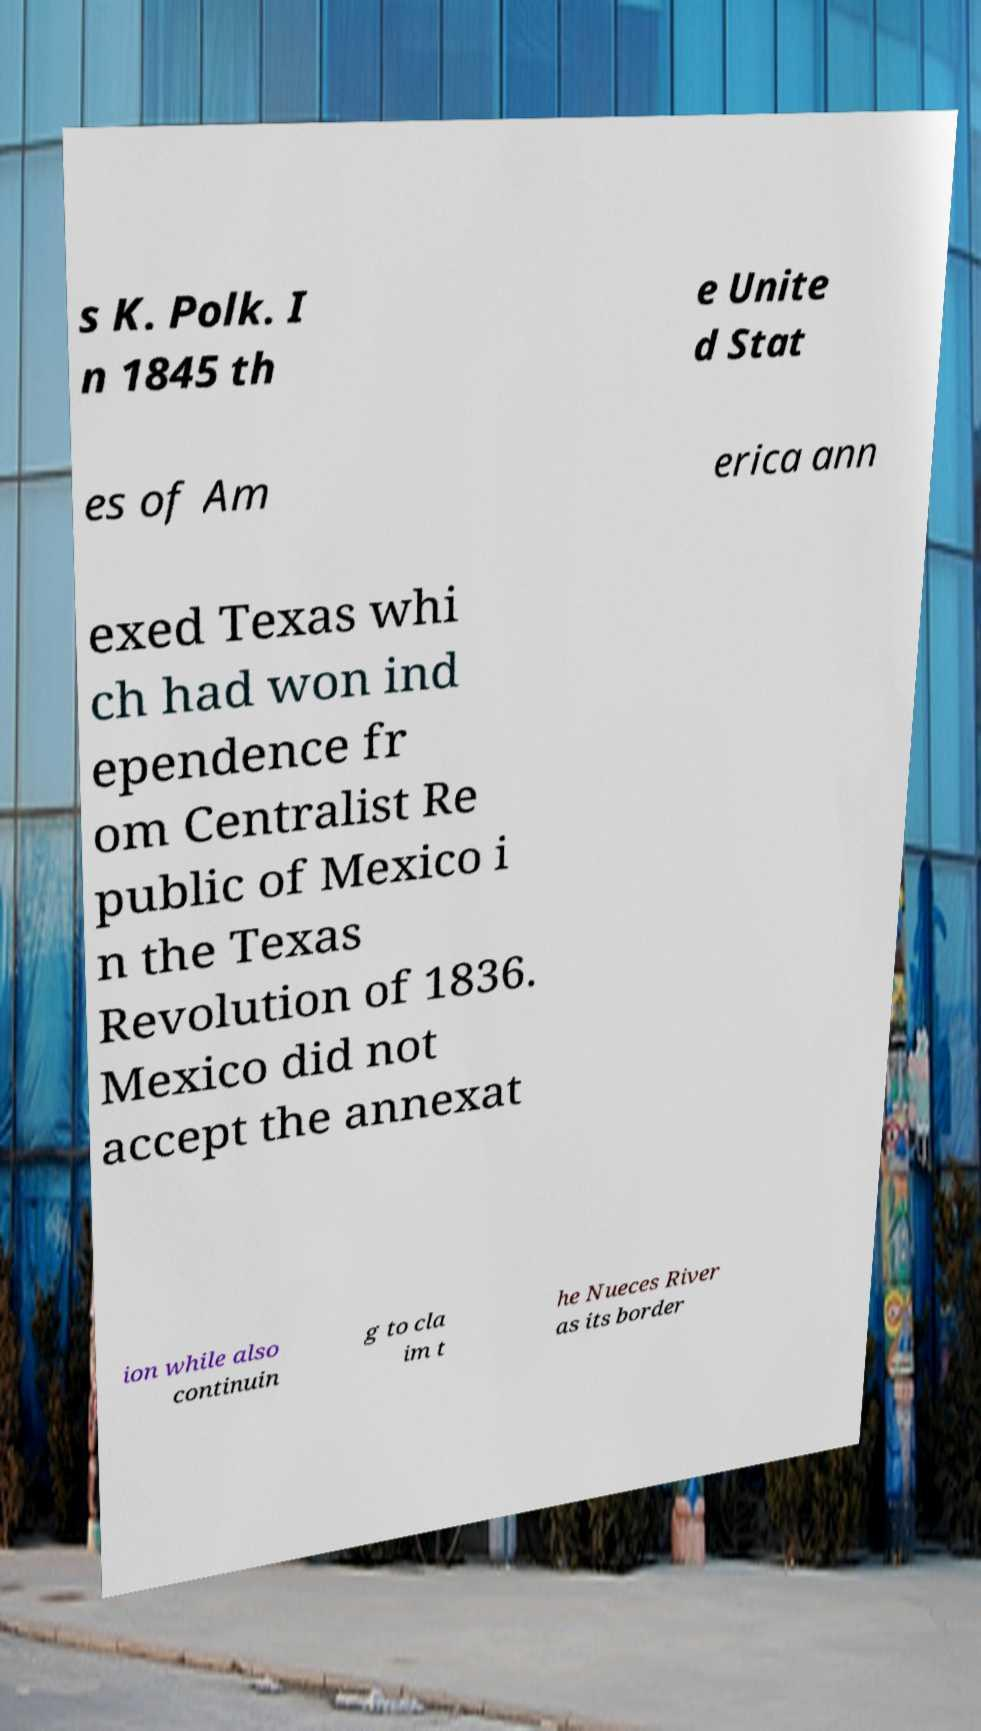Can you read and provide the text displayed in the image?This photo seems to have some interesting text. Can you extract and type it out for me? s K. Polk. I n 1845 th e Unite d Stat es of Am erica ann exed Texas whi ch had won ind ependence fr om Centralist Re public of Mexico i n the Texas Revolution of 1836. Mexico did not accept the annexat ion while also continuin g to cla im t he Nueces River as its border 